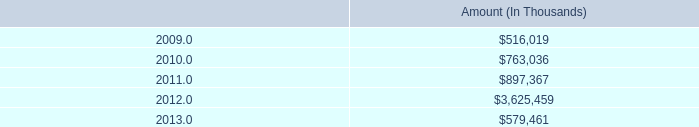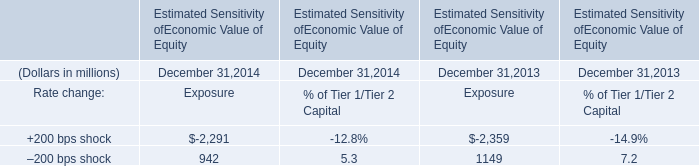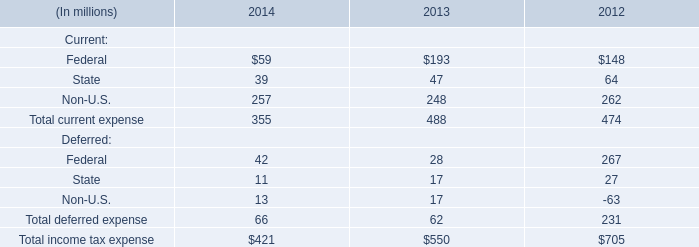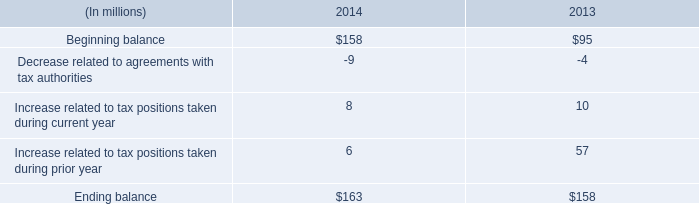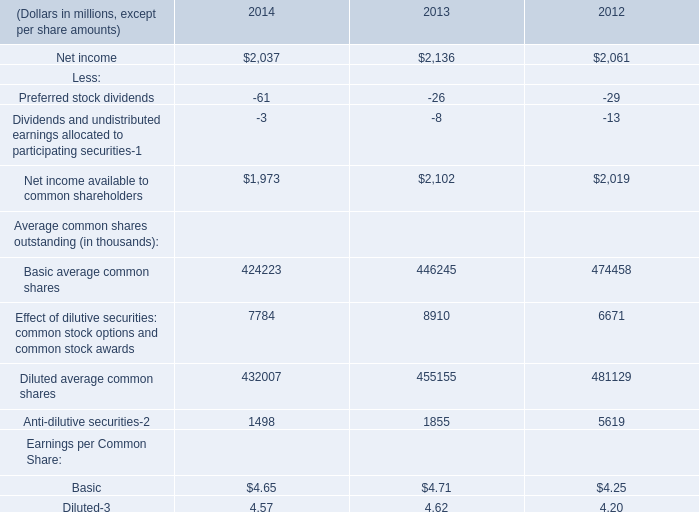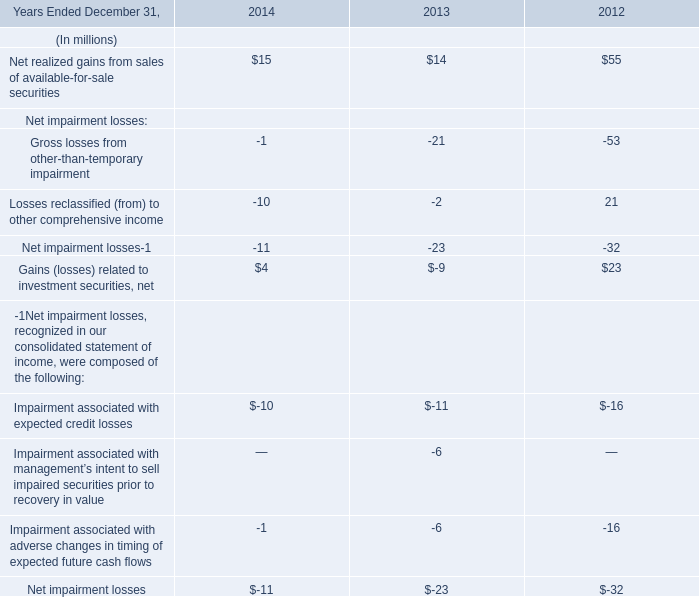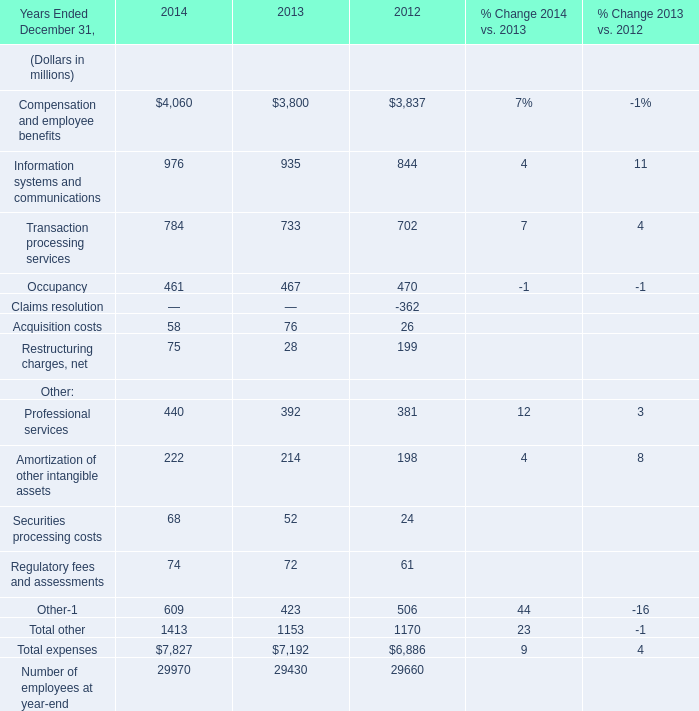What will Net realized gains from sales of available-for-sale securities be like in 2015 if it develops with the same increasing rate as current? (in million) 
Computations: (15 * (1 + ((15 - 14) / 14)))
Answer: 16.07143. 